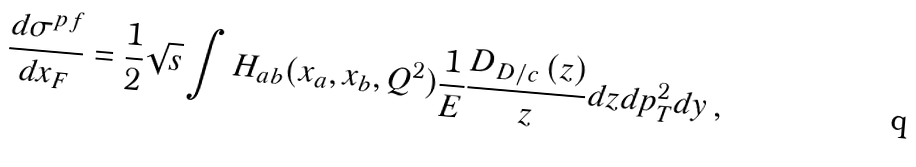<formula> <loc_0><loc_0><loc_500><loc_500>\frac { d \sigma ^ { p f } } { d x _ { F } } = \frac { 1 } { 2 } \sqrt { s } \int H _ { a b } ( x _ { a } , x _ { b } , Q ^ { 2 } ) \frac { 1 } { E } \frac { D _ { D / c } \left ( z \right ) } { z } d z d p _ { T } ^ { 2 } d y \, ,</formula> 